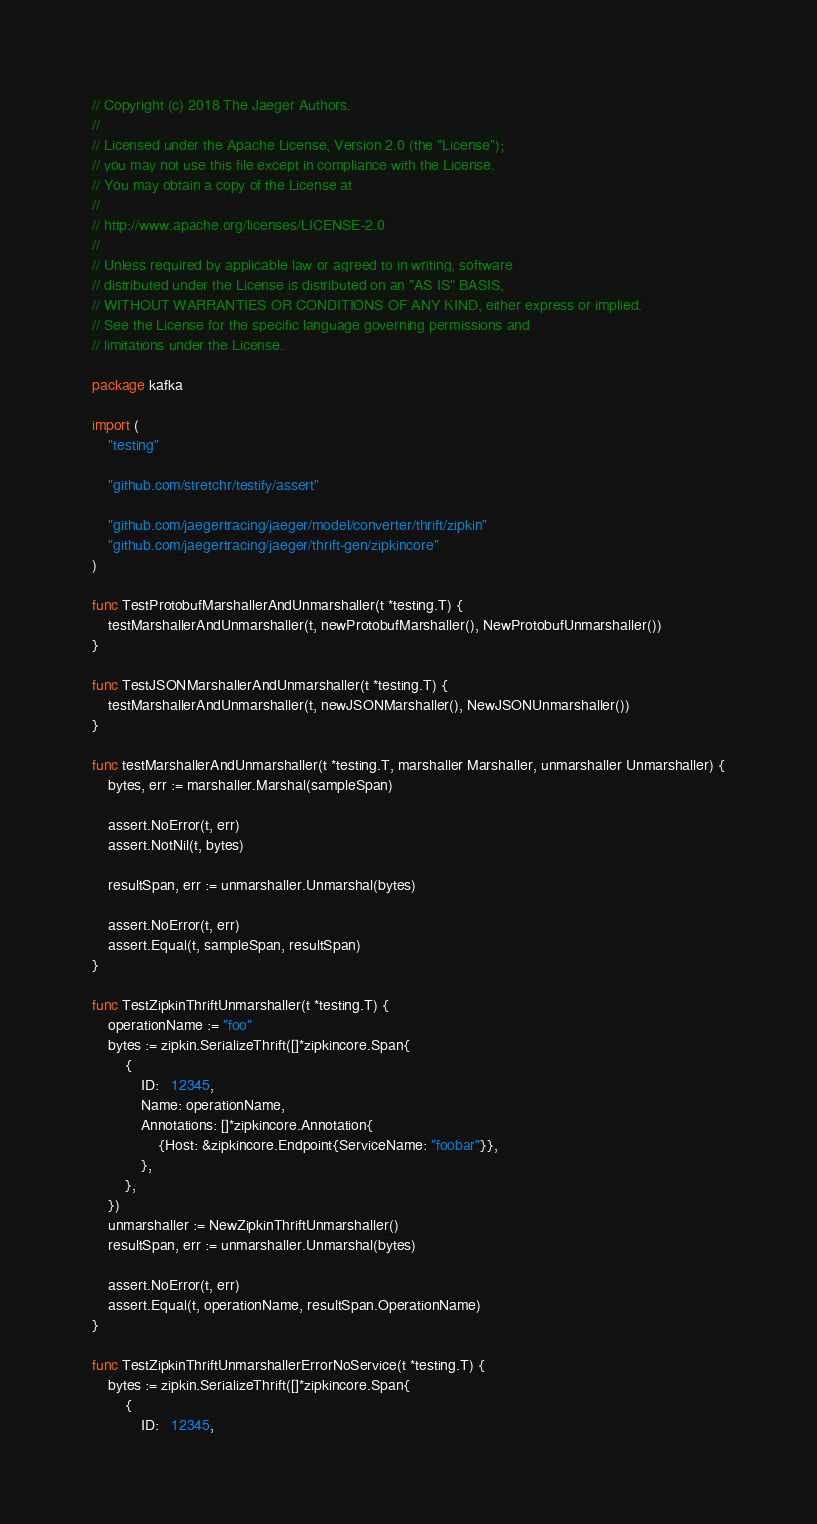Convert code to text. <code><loc_0><loc_0><loc_500><loc_500><_Go_>// Copyright (c) 2018 The Jaeger Authors.
//
// Licensed under the Apache License, Version 2.0 (the "License");
// you may not use this file except in compliance with the License.
// You may obtain a copy of the License at
//
// http://www.apache.org/licenses/LICENSE-2.0
//
// Unless required by applicable law or agreed to in writing, software
// distributed under the License is distributed on an "AS IS" BASIS,
// WITHOUT WARRANTIES OR CONDITIONS OF ANY KIND, either express or implied.
// See the License for the specific language governing permissions and
// limitations under the License.

package kafka

import (
	"testing"

	"github.com/stretchr/testify/assert"

	"github.com/jaegertracing/jaeger/model/converter/thrift/zipkin"
	"github.com/jaegertracing/jaeger/thrift-gen/zipkincore"
)

func TestProtobufMarshallerAndUnmarshaller(t *testing.T) {
	testMarshallerAndUnmarshaller(t, newProtobufMarshaller(), NewProtobufUnmarshaller())
}

func TestJSONMarshallerAndUnmarshaller(t *testing.T) {
	testMarshallerAndUnmarshaller(t, newJSONMarshaller(), NewJSONUnmarshaller())
}

func testMarshallerAndUnmarshaller(t *testing.T, marshaller Marshaller, unmarshaller Unmarshaller) {
	bytes, err := marshaller.Marshal(sampleSpan)

	assert.NoError(t, err)
	assert.NotNil(t, bytes)

	resultSpan, err := unmarshaller.Unmarshal(bytes)

	assert.NoError(t, err)
	assert.Equal(t, sampleSpan, resultSpan)
}

func TestZipkinThriftUnmarshaller(t *testing.T) {
	operationName := "foo"
	bytes := zipkin.SerializeThrift([]*zipkincore.Span{
		{
			ID:   12345,
			Name: operationName,
			Annotations: []*zipkincore.Annotation{
				{Host: &zipkincore.Endpoint{ServiceName: "foobar"}},
			},
		},
	})
	unmarshaller := NewZipkinThriftUnmarshaller()
	resultSpan, err := unmarshaller.Unmarshal(bytes)

	assert.NoError(t, err)
	assert.Equal(t, operationName, resultSpan.OperationName)
}

func TestZipkinThriftUnmarshallerErrorNoService(t *testing.T) {
	bytes := zipkin.SerializeThrift([]*zipkincore.Span{
		{
			ID:   12345,</code> 